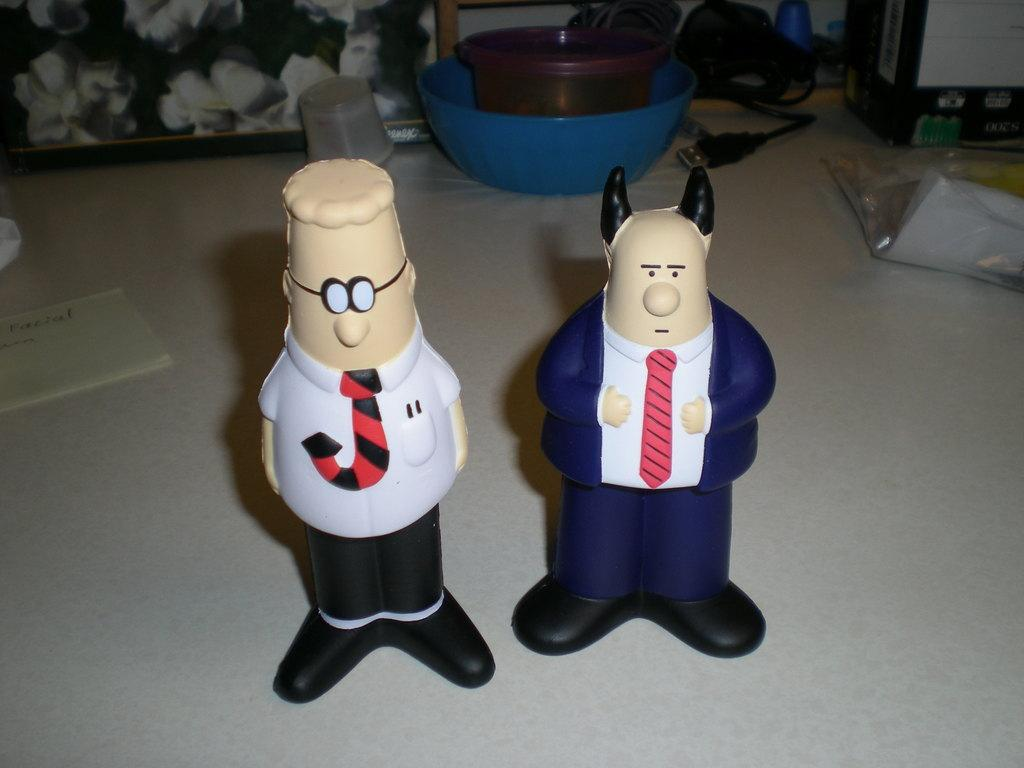What type of objects can be seen in the image? There are toys, paper, a plastic cover, cables, a box, baskets, and a frame in the image. Can you describe the paper in the image? The paper is a flat, rectangular object that can be used for writing or drawing. What is the plastic cover protecting in the image? The plastic cover is likely protecting the toys or other objects in the image. How are the cables used in the image? The cables may be used for connecting electronic devices or providing power to them. What is the purpose of the box in the image? The box could be used for storage or organization of items in the image. What are the baskets used for in the image? The baskets may be used for holding or organizing toys, paper, or other objects in the image. What is the frame used for in the image? The frame could be used for displaying a picture, poster, or other artwork in the image. How does the beginner learn to fly in the image? There is no reference to a beginner learning to fly in the image. What type of air is present in the image? There is no mention of air in the image. Is there a crook in the image? There is no crook present in the image. 